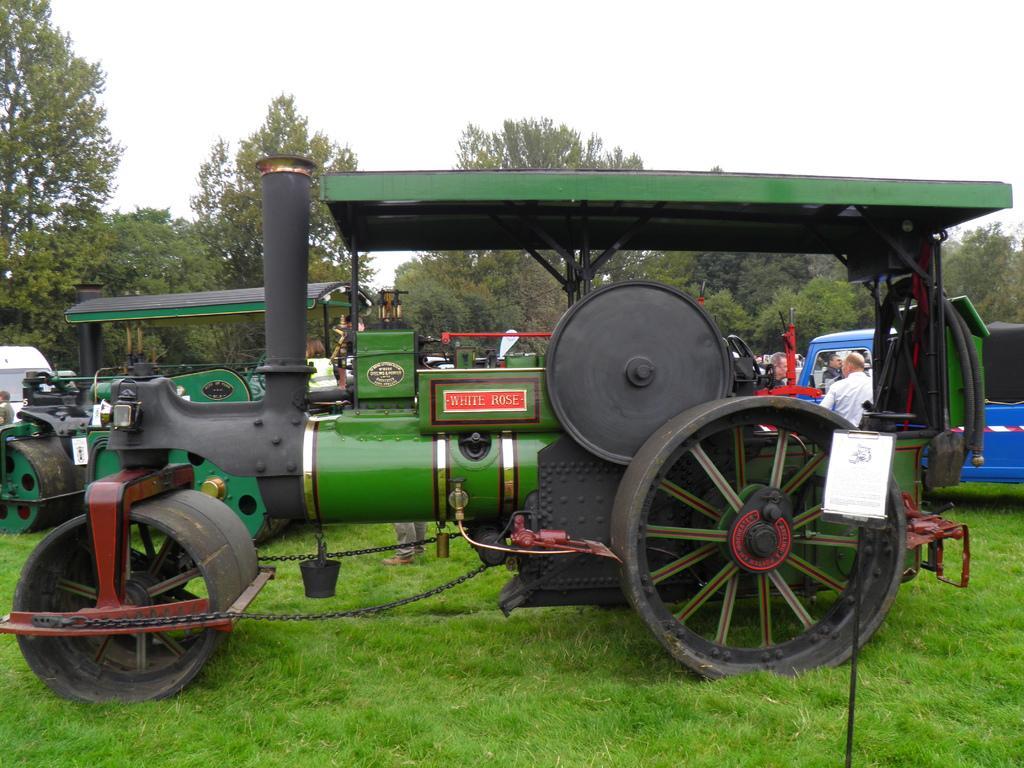Could you give a brief overview of what you see in this image? In this picture we can see a road roller here, at the bottom there is grass, we can see a person standing here, in the background there are some trees, we can see the sky at the top of the picture. 